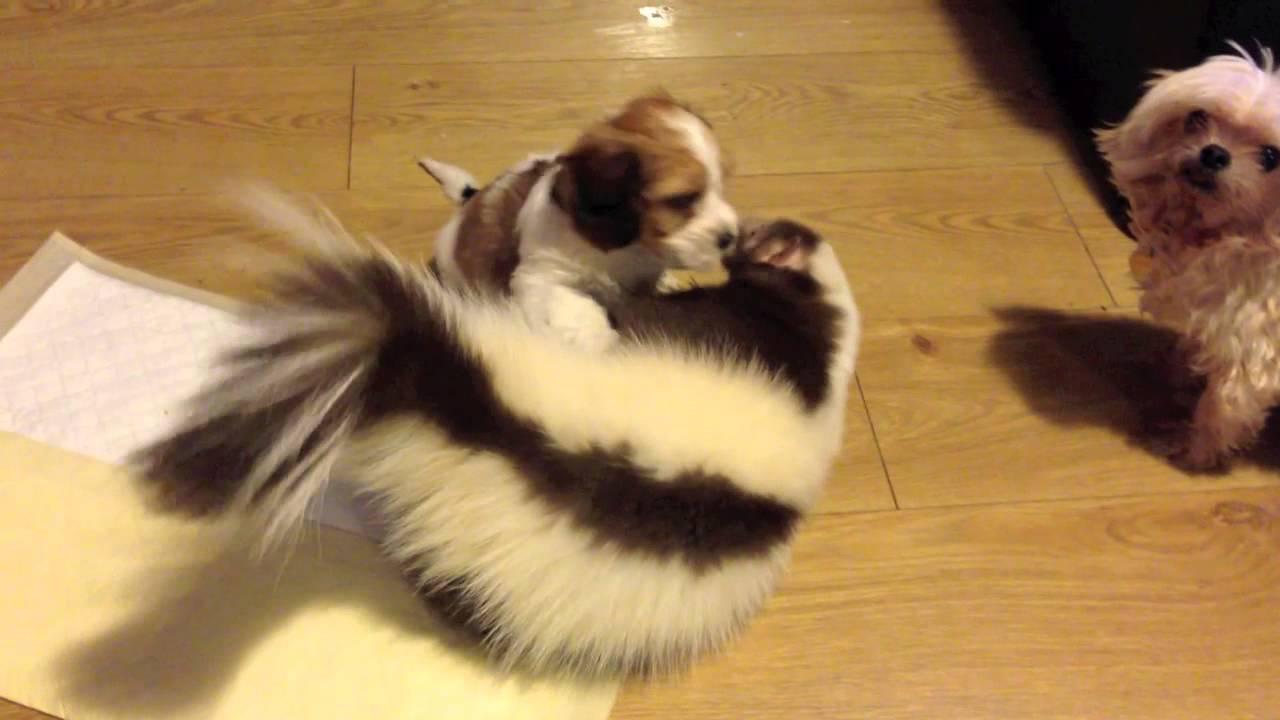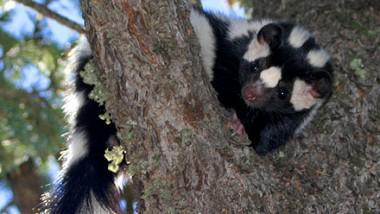The first image is the image on the left, the second image is the image on the right. Considering the images on both sides, is "The left image contains at least one skunk in basket." valid? Answer yes or no. No. The first image is the image on the left, the second image is the image on the right. For the images shown, is this caption "At least one camera-gazing skunk has both its front paws on the edge of a basket." true? Answer yes or no. No. 